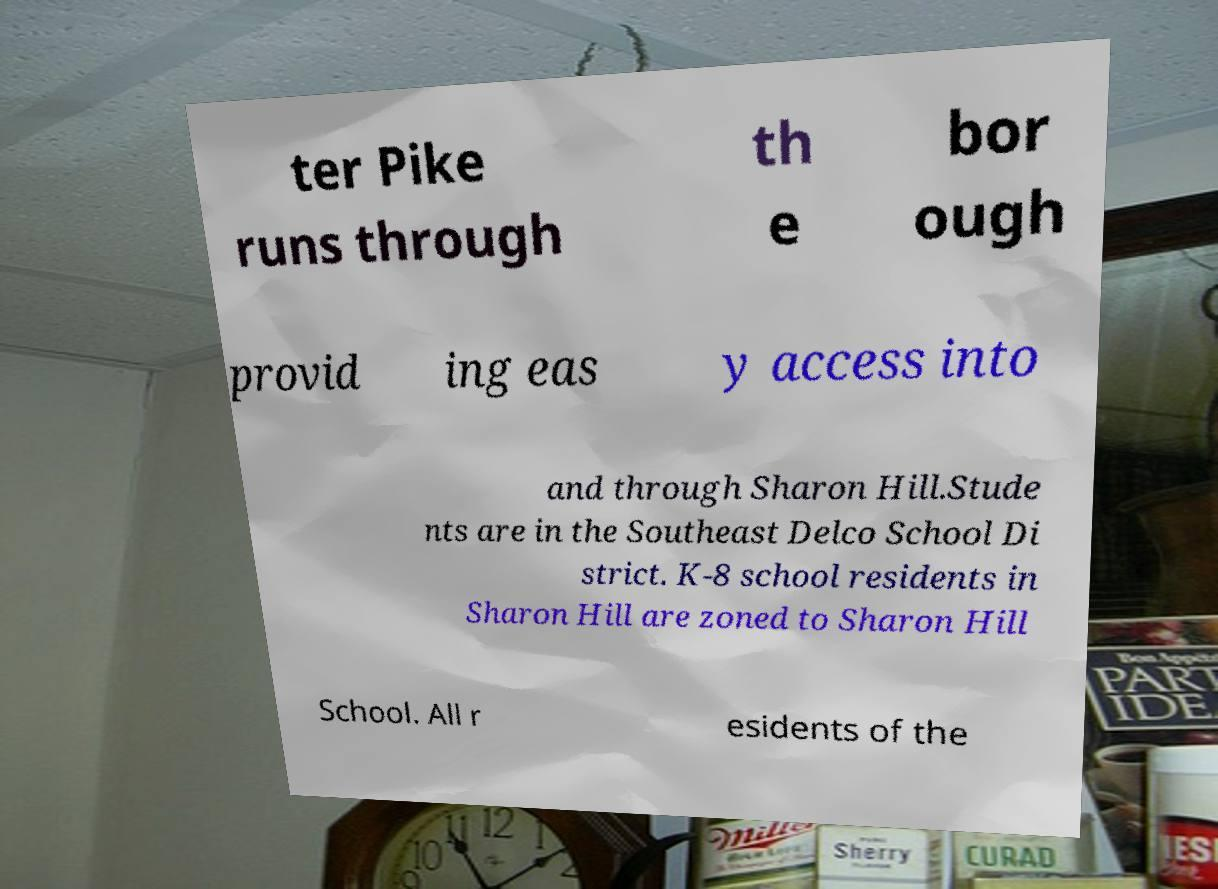For documentation purposes, I need the text within this image transcribed. Could you provide that? ter Pike runs through th e bor ough provid ing eas y access into and through Sharon Hill.Stude nts are in the Southeast Delco School Di strict. K-8 school residents in Sharon Hill are zoned to Sharon Hill School. All r esidents of the 